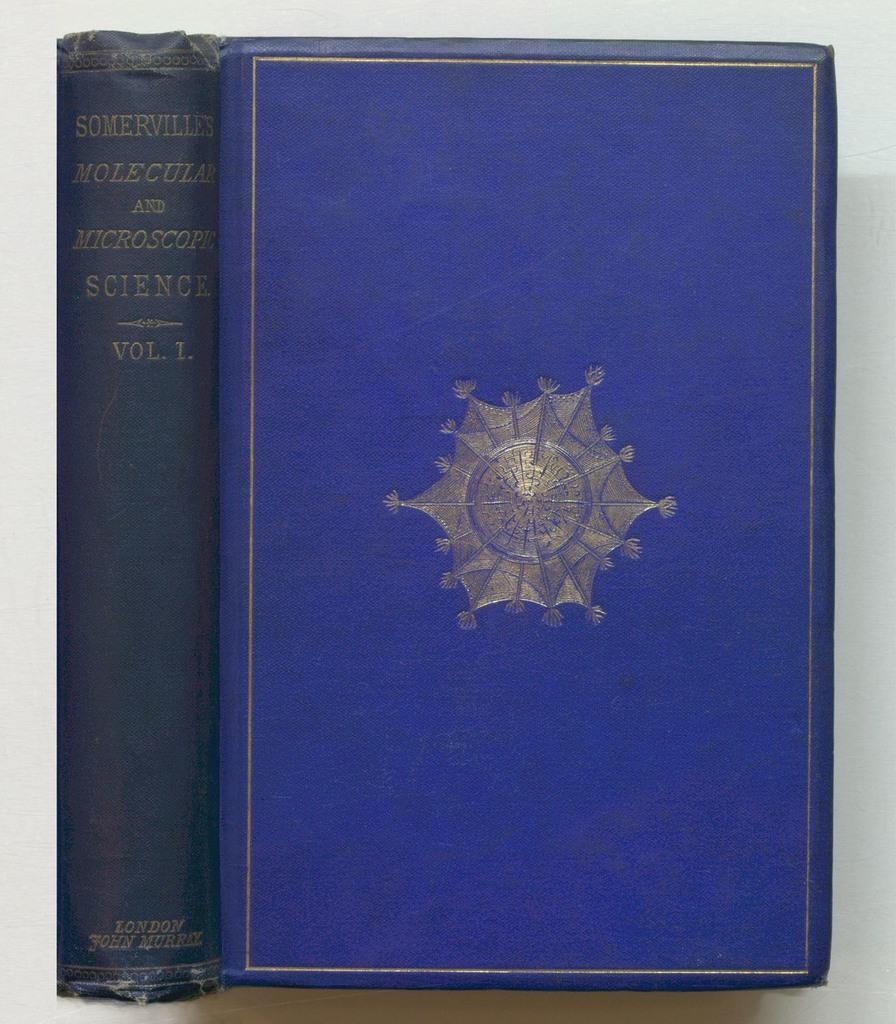<image>
Describe the image concisely. Two blue books, one titled Molecular and Microscopic Science. 